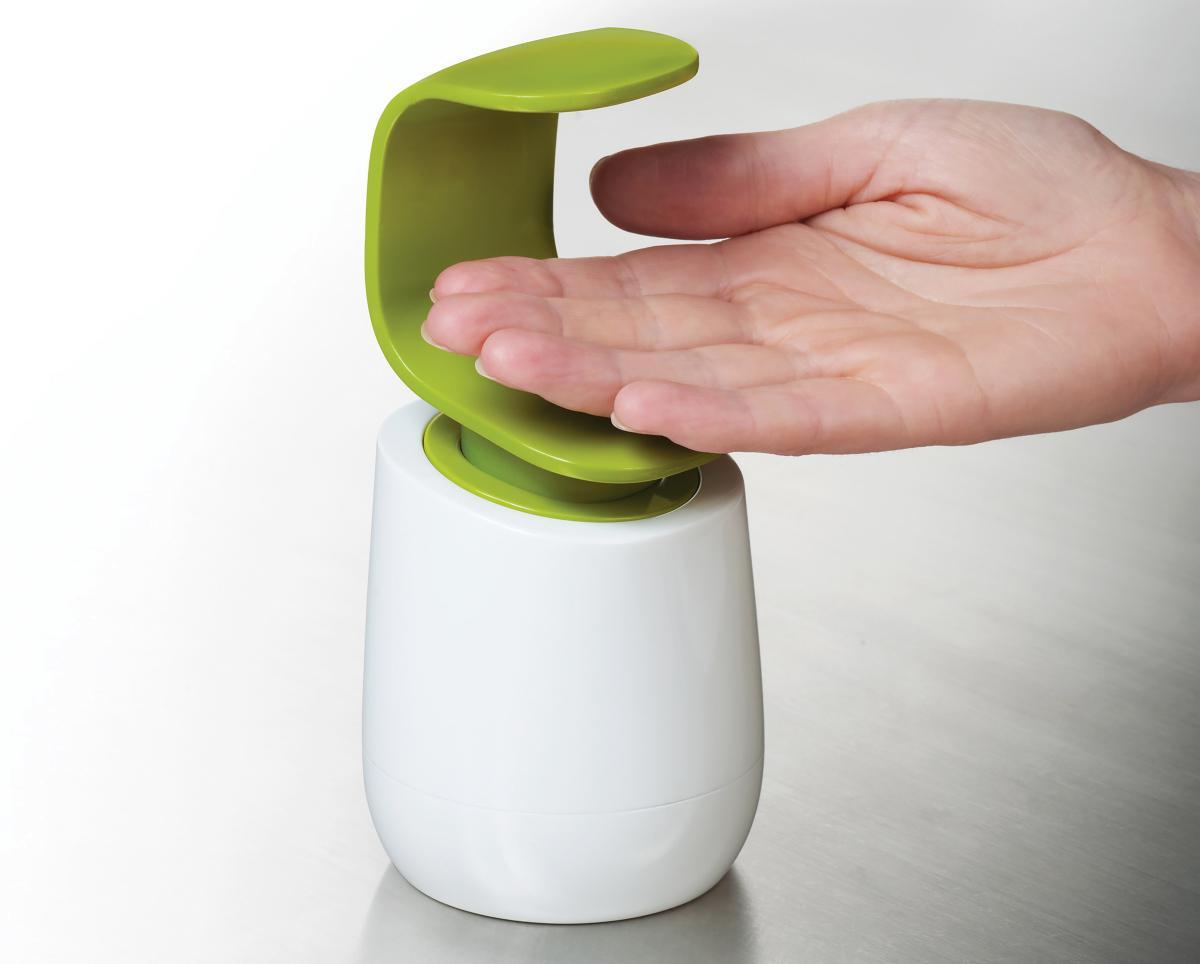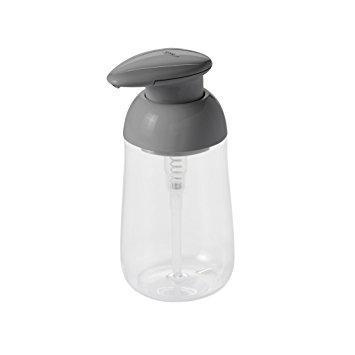The first image is the image on the left, the second image is the image on the right. For the images displayed, is the sentence "Someone is using the dispenser in one of the images." factually correct? Answer yes or no. Yes. 